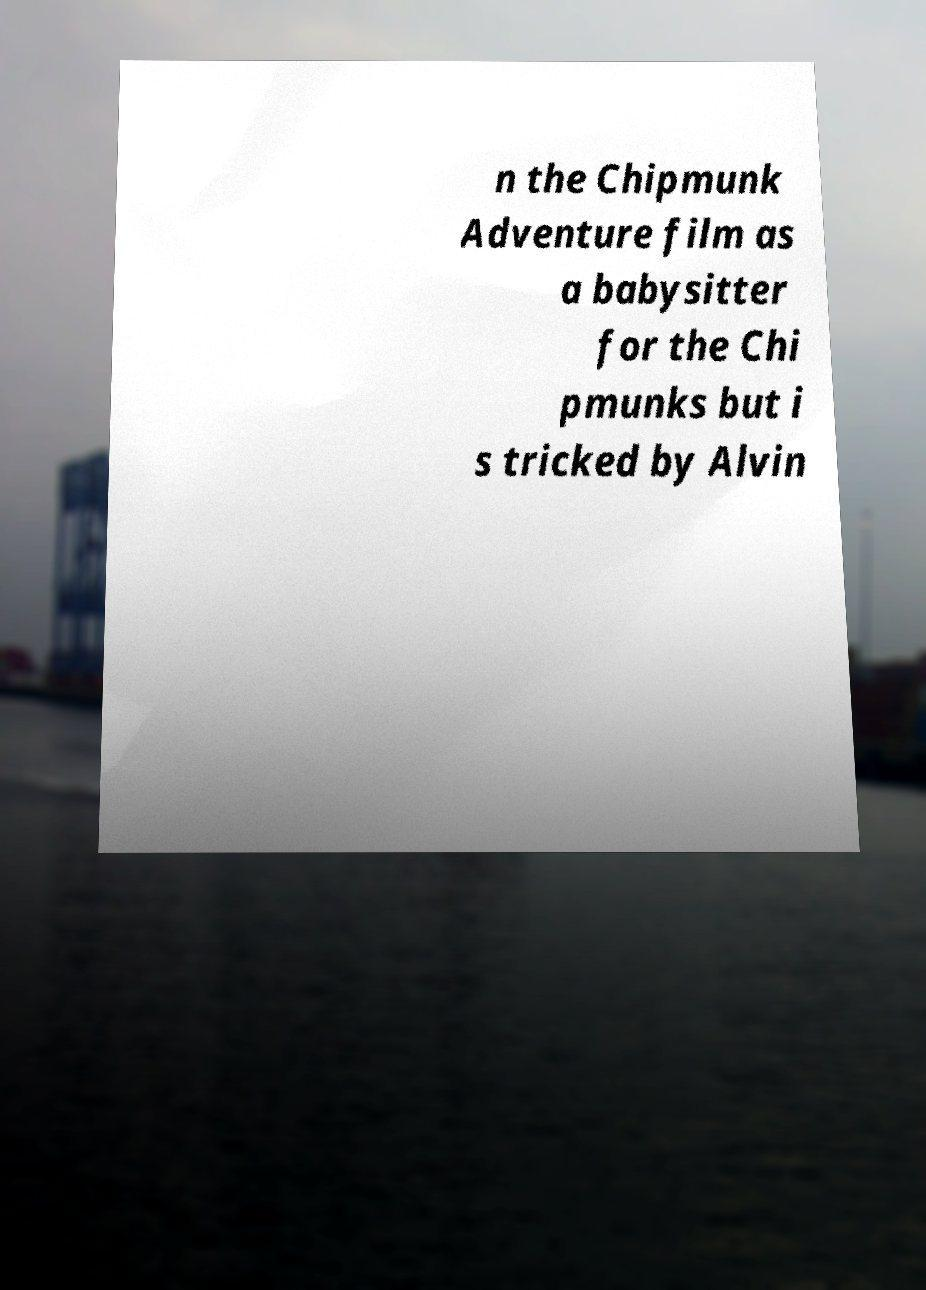Can you read and provide the text displayed in the image?This photo seems to have some interesting text. Can you extract and type it out for me? n the Chipmunk Adventure film as a babysitter for the Chi pmunks but i s tricked by Alvin 